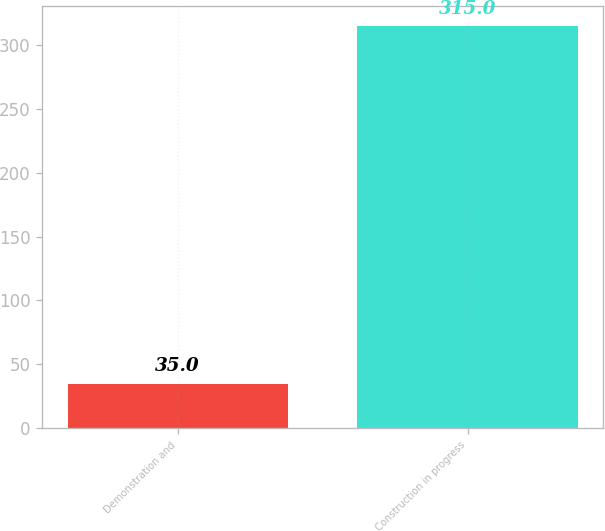<chart> <loc_0><loc_0><loc_500><loc_500><bar_chart><fcel>Demonstration and<fcel>Construction in progress<nl><fcel>35<fcel>315<nl></chart> 